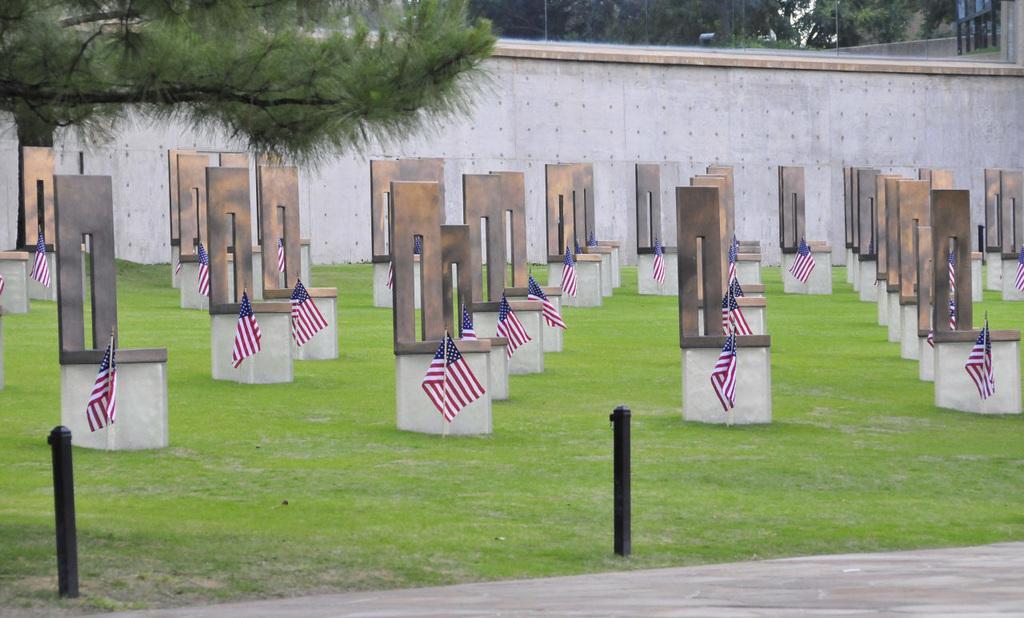Describe this image in one or two sentences. This picture shows few grave stones and we see flags and grass on the ground and we see trees and a wall. 